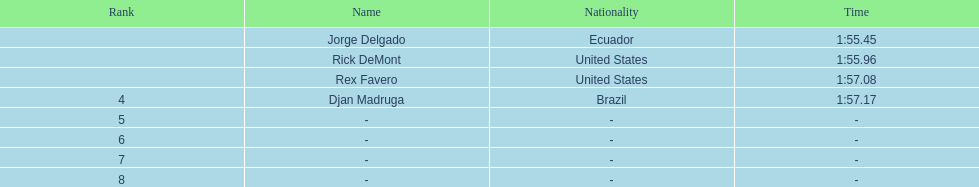What is the mean period? 1:56.42. 